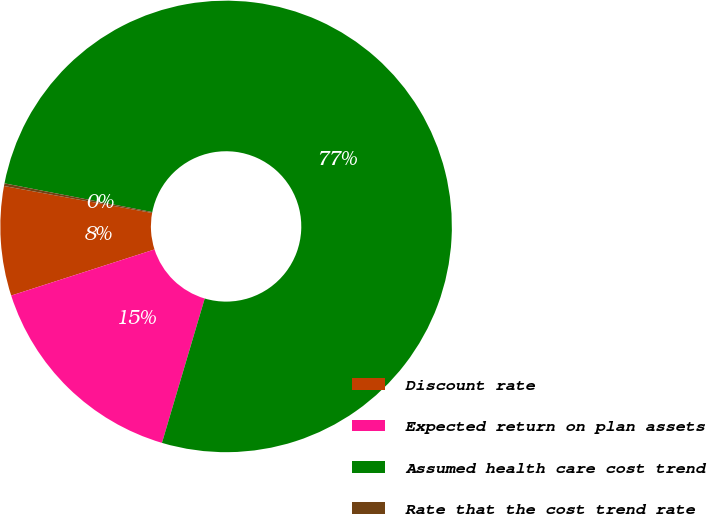<chart> <loc_0><loc_0><loc_500><loc_500><pie_chart><fcel>Discount rate<fcel>Expected return on plan assets<fcel>Assumed health care cost trend<fcel>Rate that the cost trend rate<nl><fcel>7.82%<fcel>15.46%<fcel>76.53%<fcel>0.19%<nl></chart> 